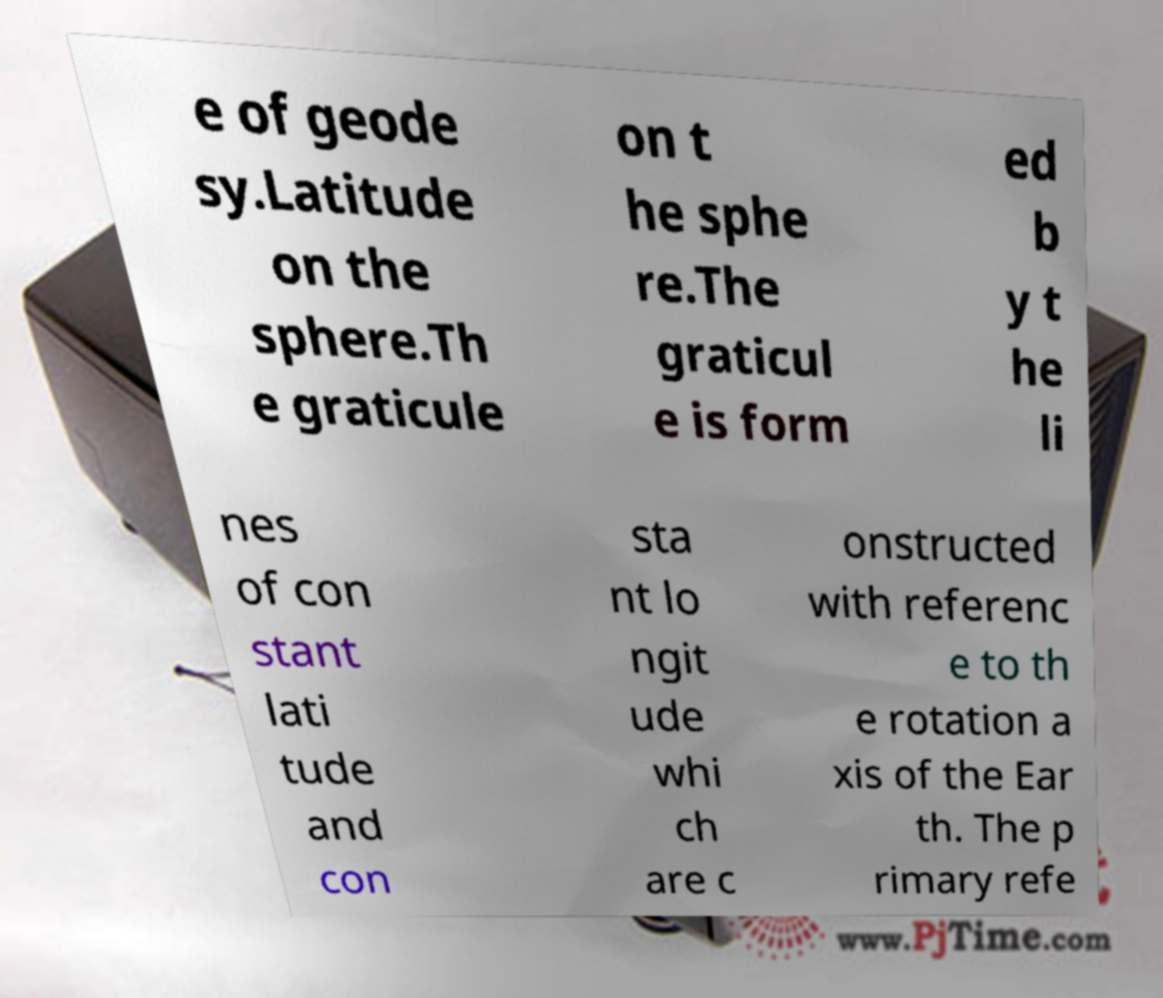There's text embedded in this image that I need extracted. Can you transcribe it verbatim? e of geode sy.Latitude on the sphere.Th e graticule on t he sphe re.The graticul e is form ed b y t he li nes of con stant lati tude and con sta nt lo ngit ude whi ch are c onstructed with referenc e to th e rotation a xis of the Ear th. The p rimary refe 